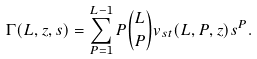Convert formula to latex. <formula><loc_0><loc_0><loc_500><loc_500>\Gamma ( L , z , s ) = \sum _ { P = 1 } ^ { L - 1 } P { L \choose { P } } v _ { s t } ( L , P , z ) s ^ { P } .</formula> 